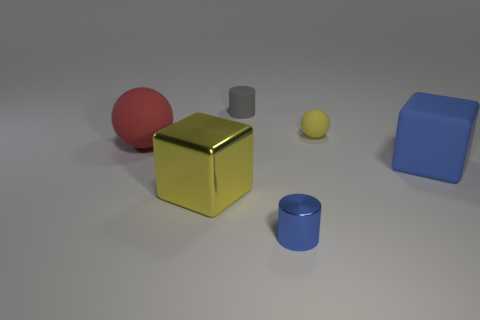Add 2 big matte blocks. How many objects exist? 8 Subtract all blocks. How many objects are left? 4 Subtract all tiny gray cylinders. Subtract all big blocks. How many objects are left? 3 Add 3 small blue objects. How many small blue objects are left? 4 Add 2 red matte balls. How many red matte balls exist? 3 Subtract 1 yellow cubes. How many objects are left? 5 Subtract all cyan balls. Subtract all gray cylinders. How many balls are left? 2 